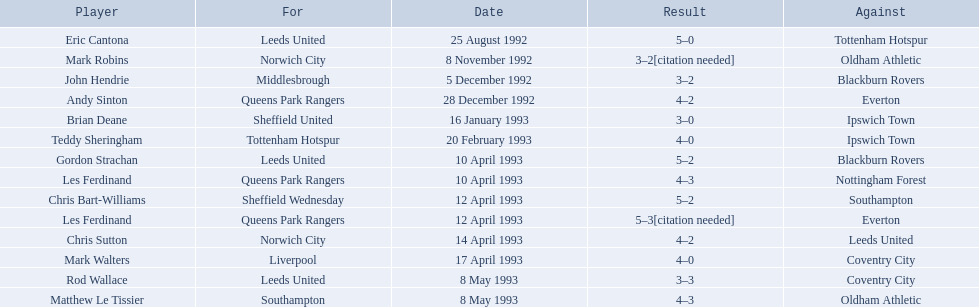Who are the players in 1992-93 fa premier league? Eric Cantona, Mark Robins, John Hendrie, Andy Sinton, Brian Deane, Teddy Sheringham, Gordon Strachan, Les Ferdinand, Chris Bart-Williams, Les Ferdinand, Chris Sutton, Mark Walters, Rod Wallace, Matthew Le Tissier. What is mark robins' result? 3–2[citation needed]. Which player has the same result? John Hendrie. 